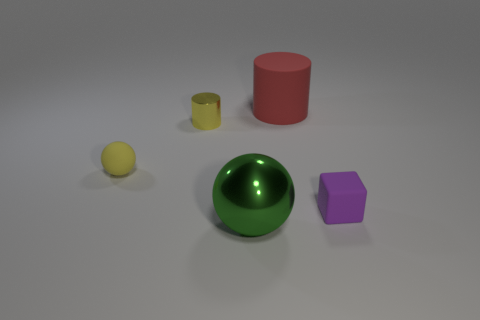Add 1 yellow rubber spheres. How many objects exist? 6 Subtract all cylinders. How many objects are left? 3 Subtract all large gray balls. Subtract all big green metal things. How many objects are left? 4 Add 1 tiny yellow matte balls. How many tiny yellow matte balls are left? 2 Add 3 matte objects. How many matte objects exist? 6 Subtract 0 blue cubes. How many objects are left? 5 